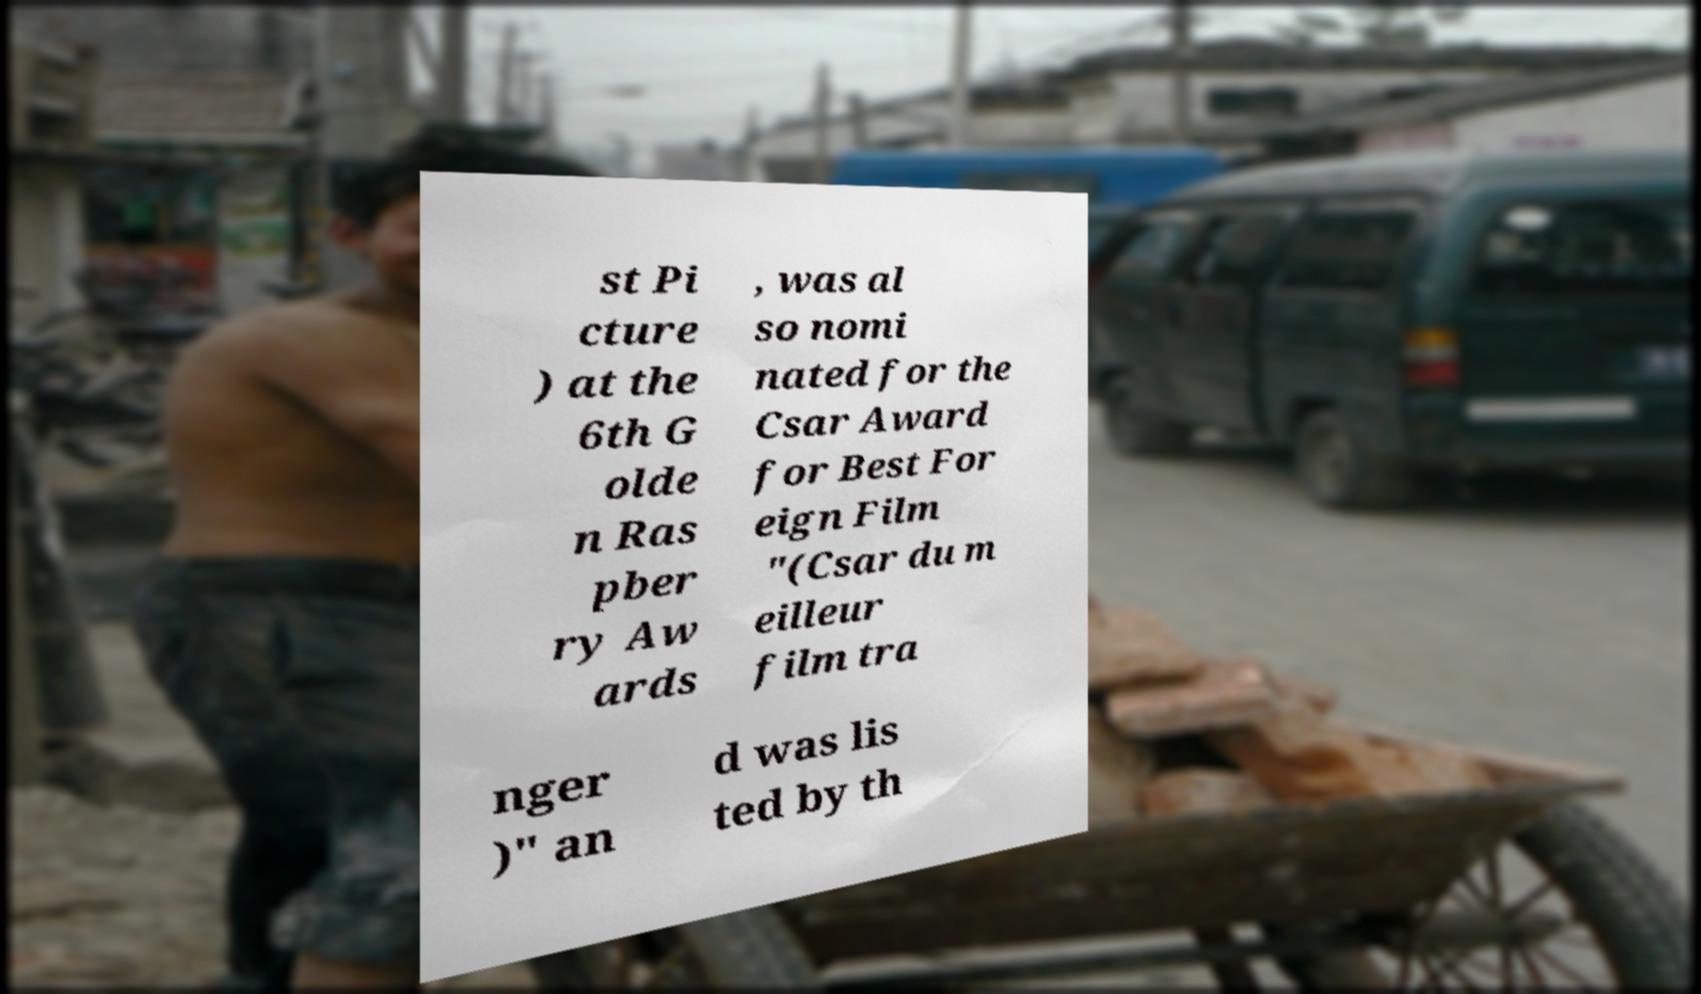Can you accurately transcribe the text from the provided image for me? st Pi cture ) at the 6th G olde n Ras pber ry Aw ards , was al so nomi nated for the Csar Award for Best For eign Film "(Csar du m eilleur film tra nger )" an d was lis ted by th 